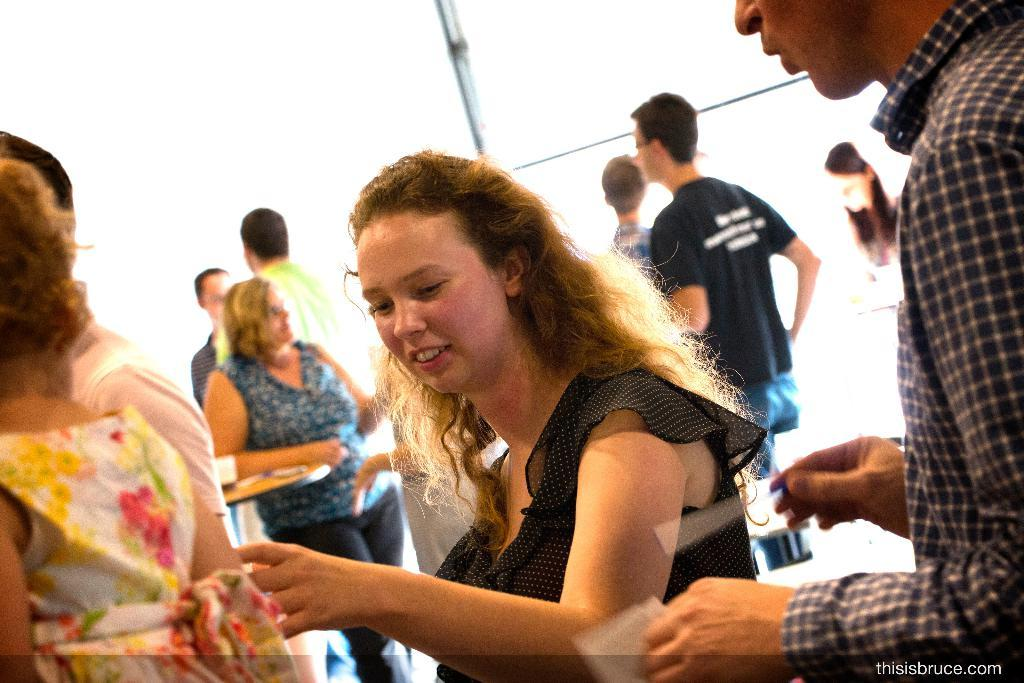How many people are in the image? There are many people in the image. Can you describe the woman in the front of the image? A woman wearing a black dress is in the front of the image. Who is standing beside the woman? There is a man standing beside the woman. What color is the background of the image? The background of the image is white. What type of property can be seen in the background of the image? There is no property visible in the image; the background is white. Can you describe the cave that the people are standing in front of? There is no cave present in the image; it features a group of people with a woman in a black dress and a man standing beside her. 